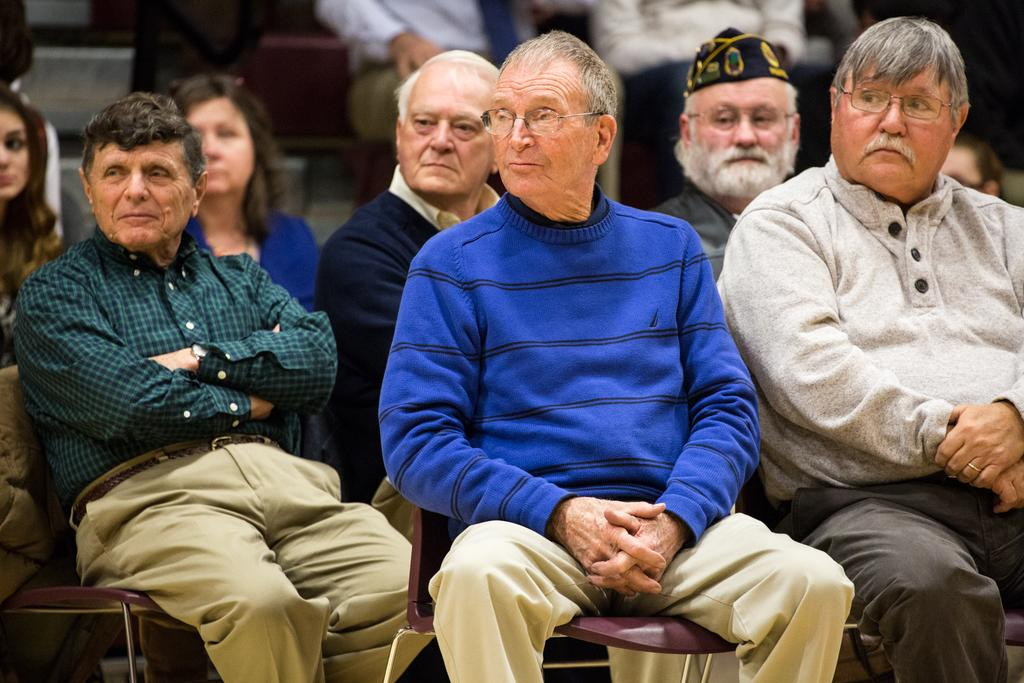What is the main subject of the image? The main subject of the image is a group of people. What are the people in the image doing? The people in the image are sitting on chairs. Can you describe any specific features of the people in the group? Some people in the group are wearing spectacles, and one person is wearing a cap. How many wings can be seen on the people in the image? There are no wings visible on the people in the image. What type of body is present in the image? There is no specific body present in the image; it features a group of people. 